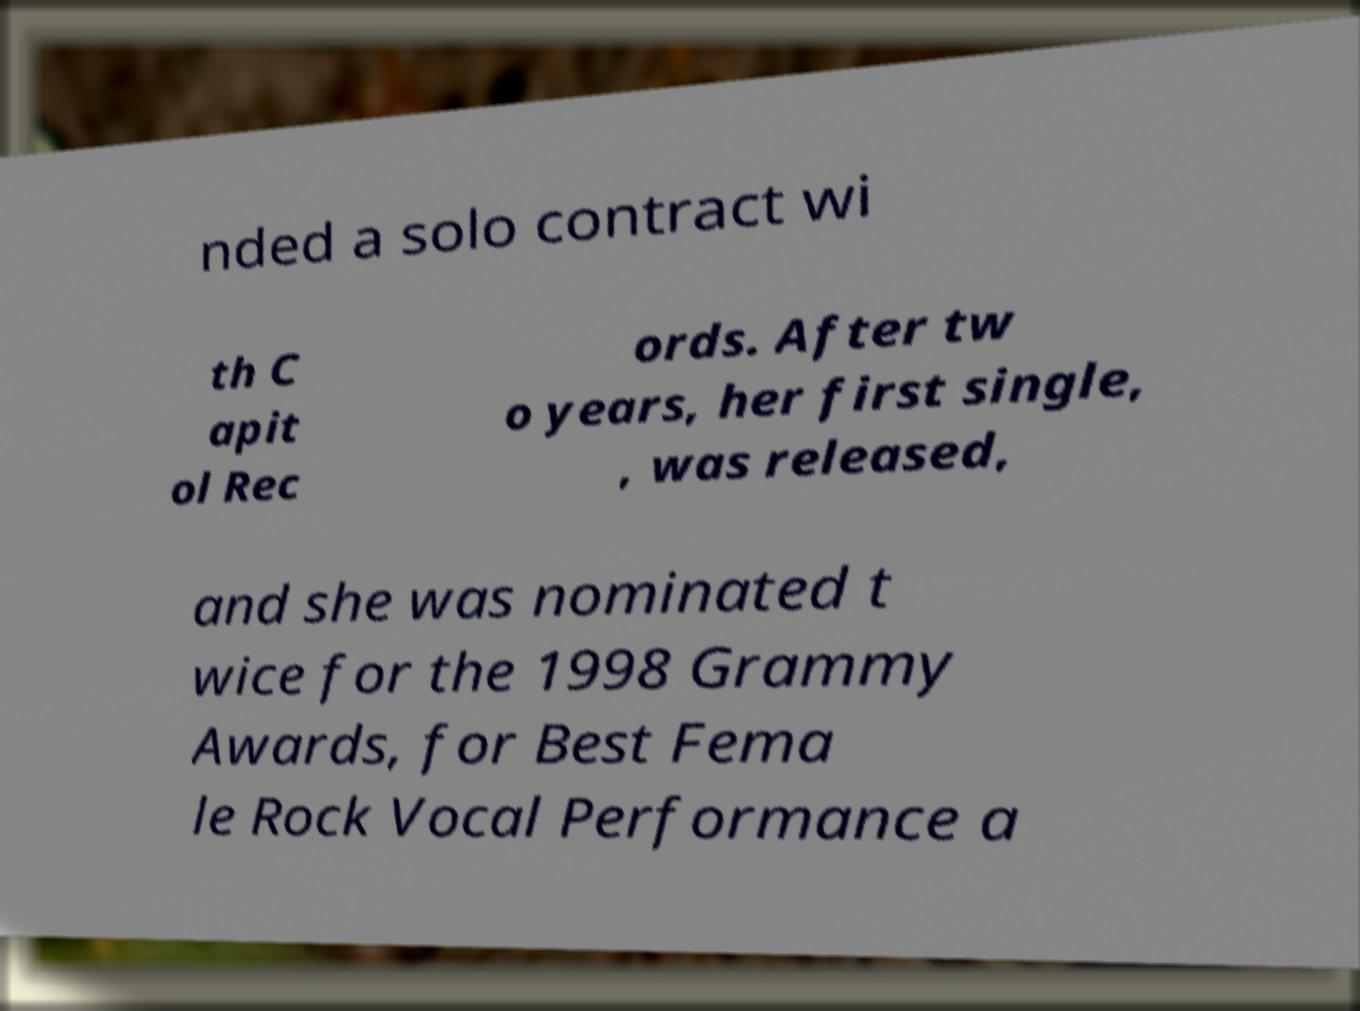Can you accurately transcribe the text from the provided image for me? nded a solo contract wi th C apit ol Rec ords. After tw o years, her first single, , was released, and she was nominated t wice for the 1998 Grammy Awards, for Best Fema le Rock Vocal Performance a 